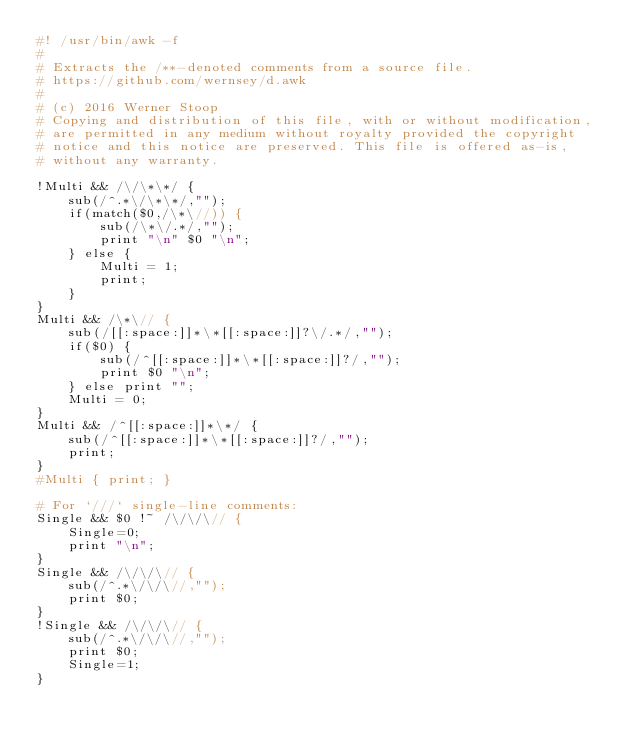<code> <loc_0><loc_0><loc_500><loc_500><_Awk_>#! /usr/bin/awk -f
#
# Extracts the /**-denoted comments from a source file.
# https://github.com/wernsey/d.awk
#
# (c) 2016 Werner Stoop
# Copying and distribution of this file, with or without modification,
# are permitted in any medium without royalty provided the copyright
# notice and this notice are preserved. This file is offered as-is,
# without any warranty.

!Multi && /\/\*\*/ {
    sub(/^.*\/\*\*/,"");
    if(match($0,/\*\//)) {
        sub(/\*\/.*/,"");
        print "\n" $0 "\n";
    } else {
        Multi = 1;
        print;
    }
}
Multi && /\*\// {
    sub(/[[:space:]]*\*[[:space:]]?\/.*/,"");
    if($0) {
        sub(/^[[:space:]]*\*[[:space:]]?/,"");
        print $0 "\n";
    } else print "";
    Multi = 0;
}
Multi && /^[[:space:]]*\*/ {
    sub(/^[[:space:]]*\*[[:space:]]?/,"");
    print;
}
#Multi { print; }

# For `///` single-line comments:
Single && $0 !~ /\/\/\// {
    Single=0;
    print "\n";
}
Single && /\/\/\// {
    sub(/^.*\/\/\//,"");
    print $0;
}
!Single && /\/\/\// {
    sub(/^.*\/\/\//,"");
    print $0;
    Single=1;
}</code> 